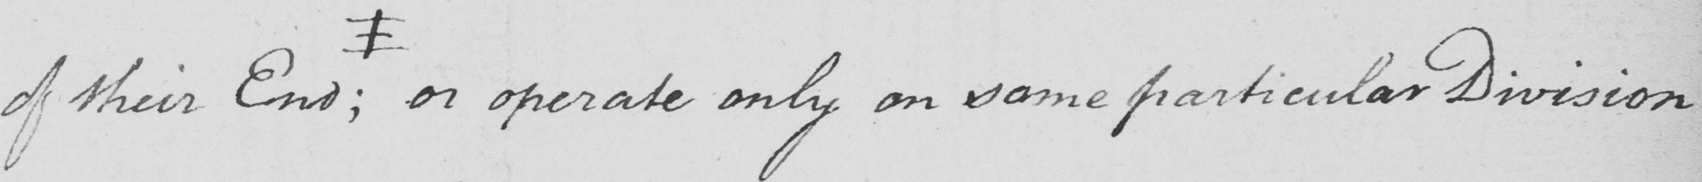Please transcribe the handwritten text in this image. of their End  ; # or operate only on some particular Division 